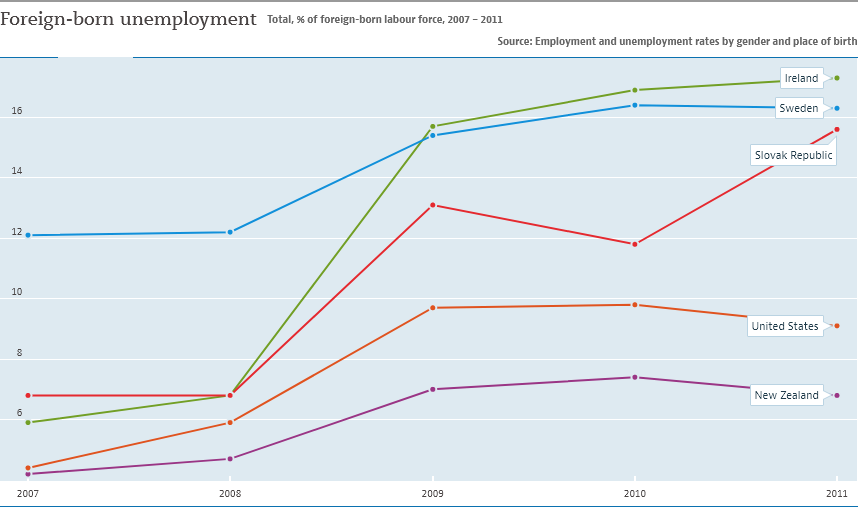Outline some significant characteristics in this image. In 2011, the foreign-born population in Slovakia experienced the highest recorded level of unemployment. At what point did the lines representing Ireland and Sweden intersect each other? 